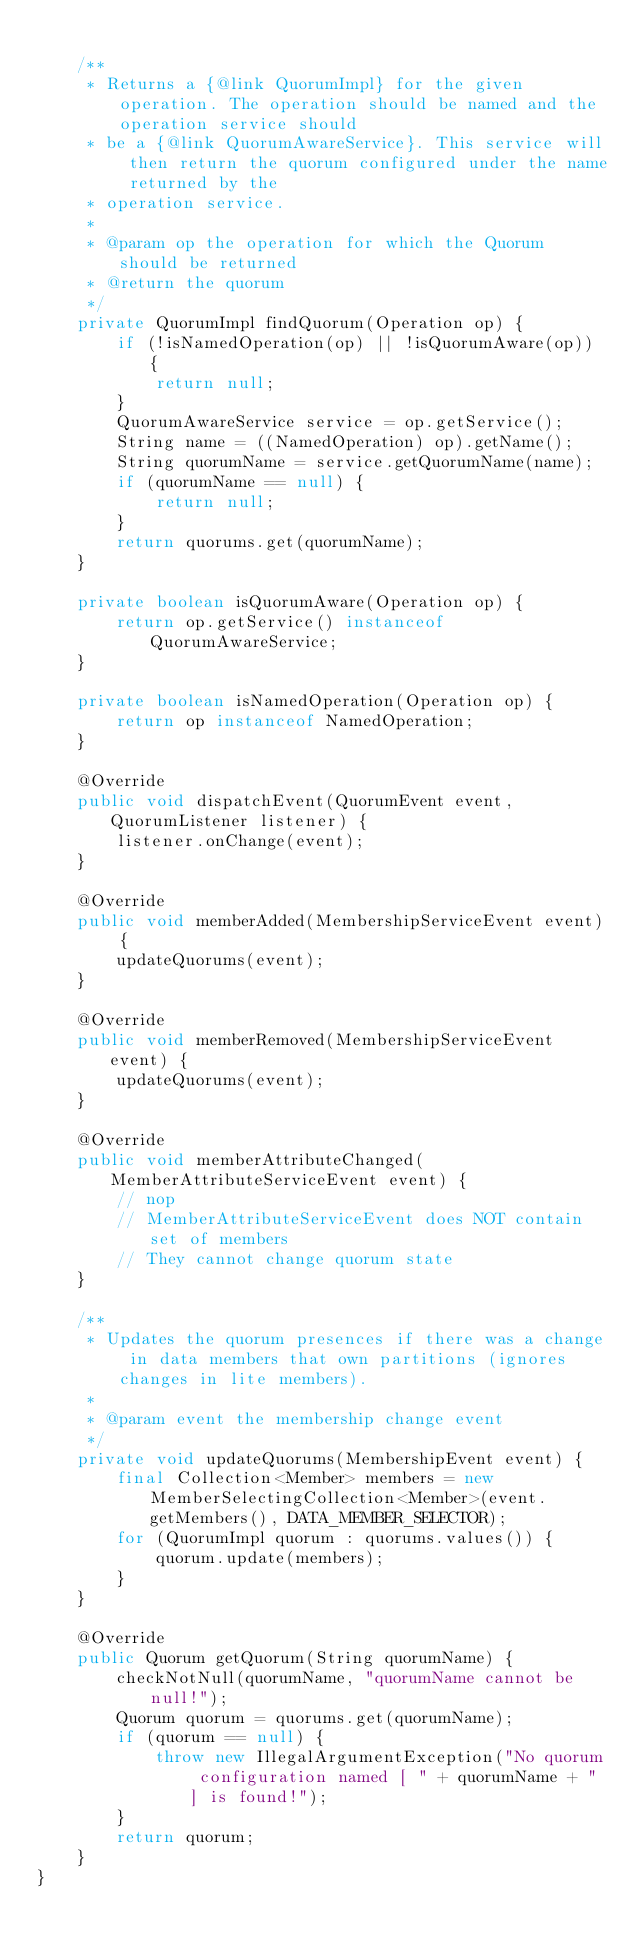Convert code to text. <code><loc_0><loc_0><loc_500><loc_500><_Java_>
    /**
     * Returns a {@link QuorumImpl} for the given operation. The operation should be named and the operation service should
     * be a {@link QuorumAwareService}. This service will then return the quorum configured under the name returned by the
     * operation service.
     *
     * @param op the operation for which the Quorum should be returned
     * @return the quorum
     */
    private QuorumImpl findQuorum(Operation op) {
        if (!isNamedOperation(op) || !isQuorumAware(op)) {
            return null;
        }
        QuorumAwareService service = op.getService();
        String name = ((NamedOperation) op).getName();
        String quorumName = service.getQuorumName(name);
        if (quorumName == null) {
            return null;
        }
        return quorums.get(quorumName);
    }

    private boolean isQuorumAware(Operation op) {
        return op.getService() instanceof QuorumAwareService;
    }

    private boolean isNamedOperation(Operation op) {
        return op instanceof NamedOperation;
    }

    @Override
    public void dispatchEvent(QuorumEvent event, QuorumListener listener) {
        listener.onChange(event);
    }

    @Override
    public void memberAdded(MembershipServiceEvent event) {
        updateQuorums(event);
    }

    @Override
    public void memberRemoved(MembershipServiceEvent event) {
        updateQuorums(event);
    }

    @Override
    public void memberAttributeChanged(MemberAttributeServiceEvent event) {
        // nop
        // MemberAttributeServiceEvent does NOT contain set of members
        // They cannot change quorum state
    }

    /**
     * Updates the quorum presences if there was a change in data members that own partitions (ignores changes in lite members).
     *
     * @param event the membership change event
     */
    private void updateQuorums(MembershipEvent event) {
        final Collection<Member> members = new MemberSelectingCollection<Member>(event.getMembers(), DATA_MEMBER_SELECTOR);
        for (QuorumImpl quorum : quorums.values()) {
            quorum.update(members);
        }
    }

    @Override
    public Quorum getQuorum(String quorumName) {
        checkNotNull(quorumName, "quorumName cannot be null!");
        Quorum quorum = quorums.get(quorumName);
        if (quorum == null) {
            throw new IllegalArgumentException("No quorum configuration named [ " + quorumName + " ] is found!");
        }
        return quorum;
    }
}
</code> 